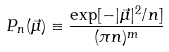Convert formula to latex. <formula><loc_0><loc_0><loc_500><loc_500>P _ { n } ( \vec { \mu } ) \equiv \frac { \exp [ - | \vec { \mu } | ^ { 2 } / n ] } { ( \pi n ) ^ { m } }</formula> 